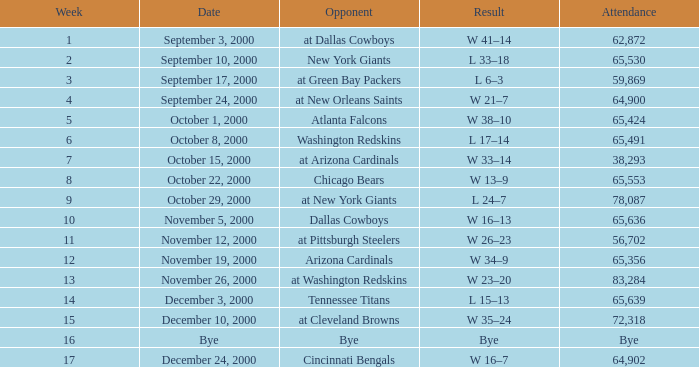What was the turnout for week 2? 65530.0. 